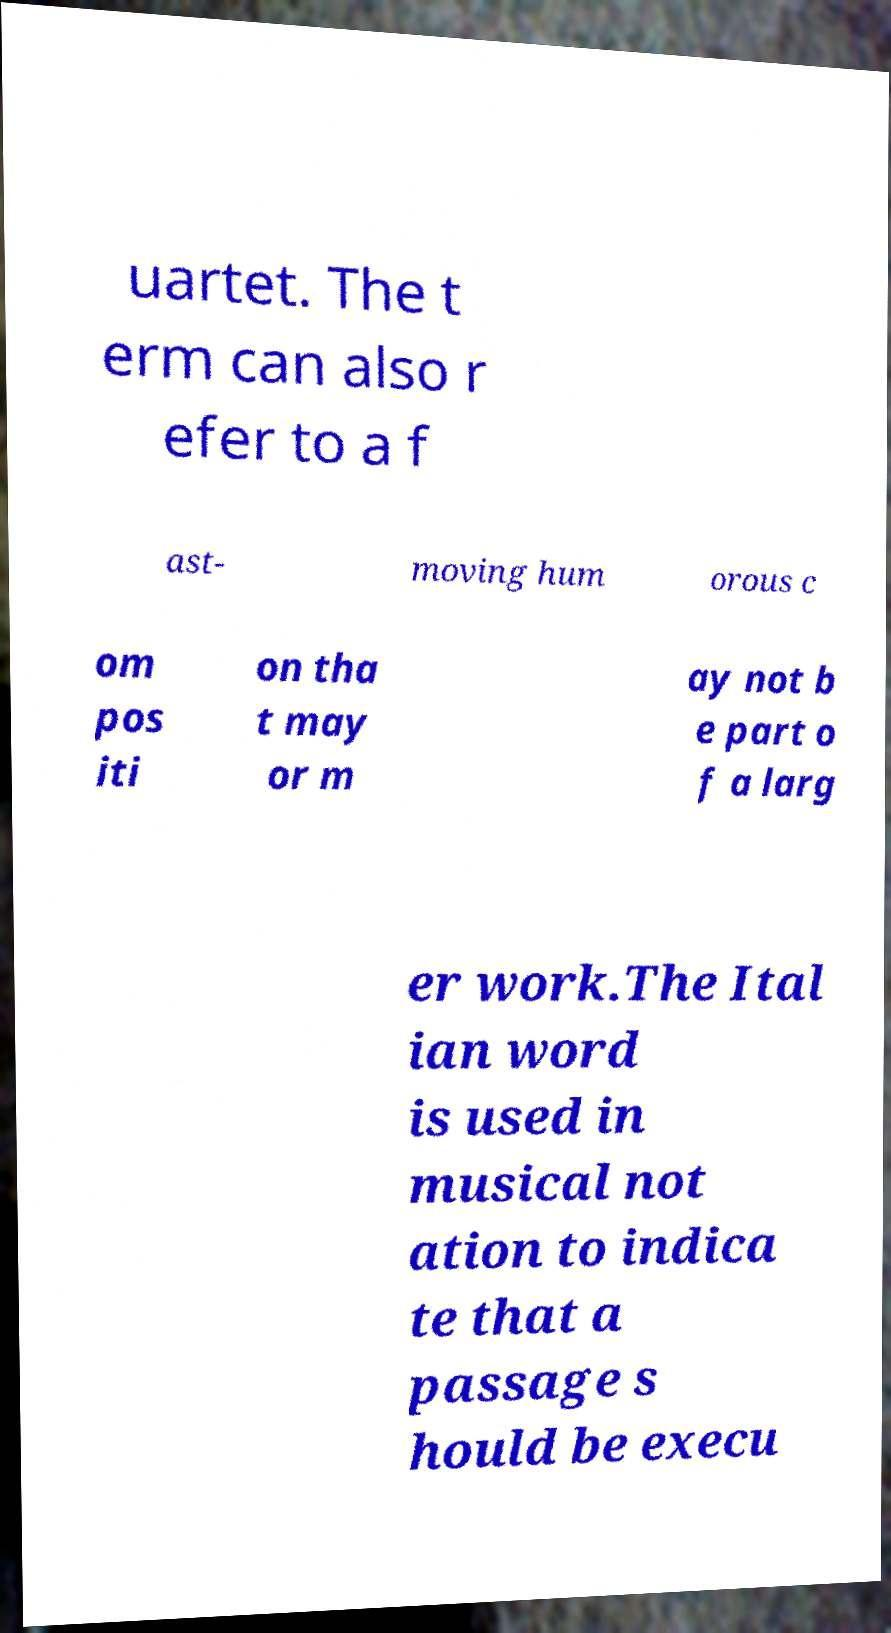Can you accurately transcribe the text from the provided image for me? uartet. The t erm can also r efer to a f ast- moving hum orous c om pos iti on tha t may or m ay not b e part o f a larg er work.The Ital ian word is used in musical not ation to indica te that a passage s hould be execu 